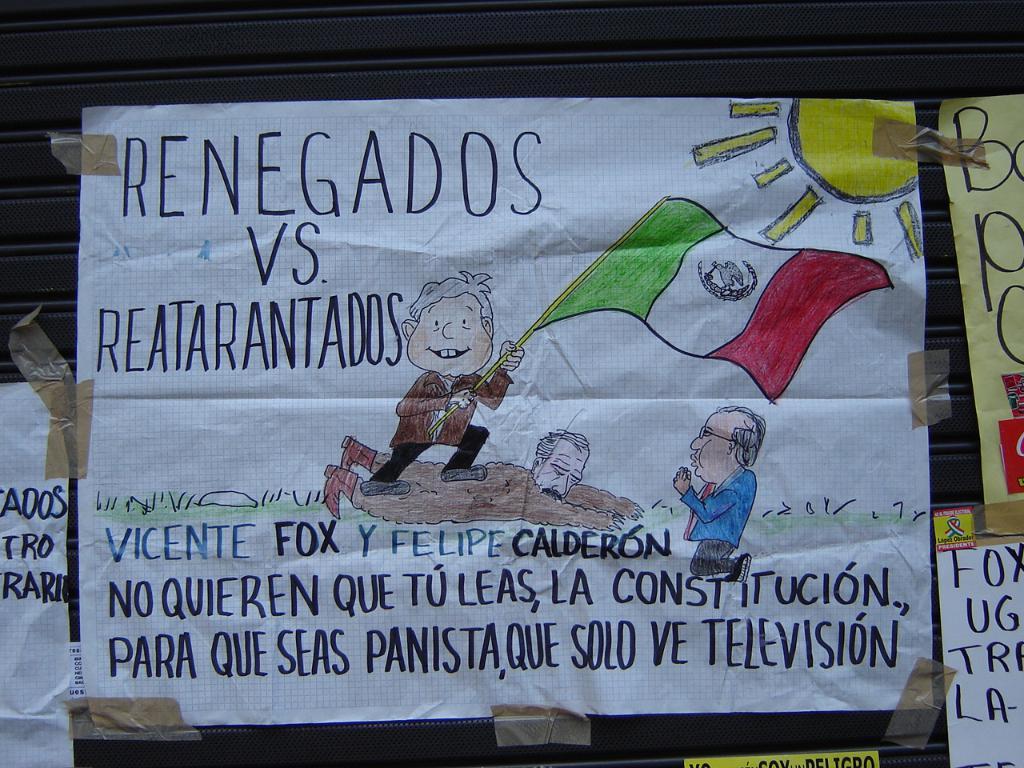What's the title?
Provide a succinct answer. Renegados vs reatarantados. 